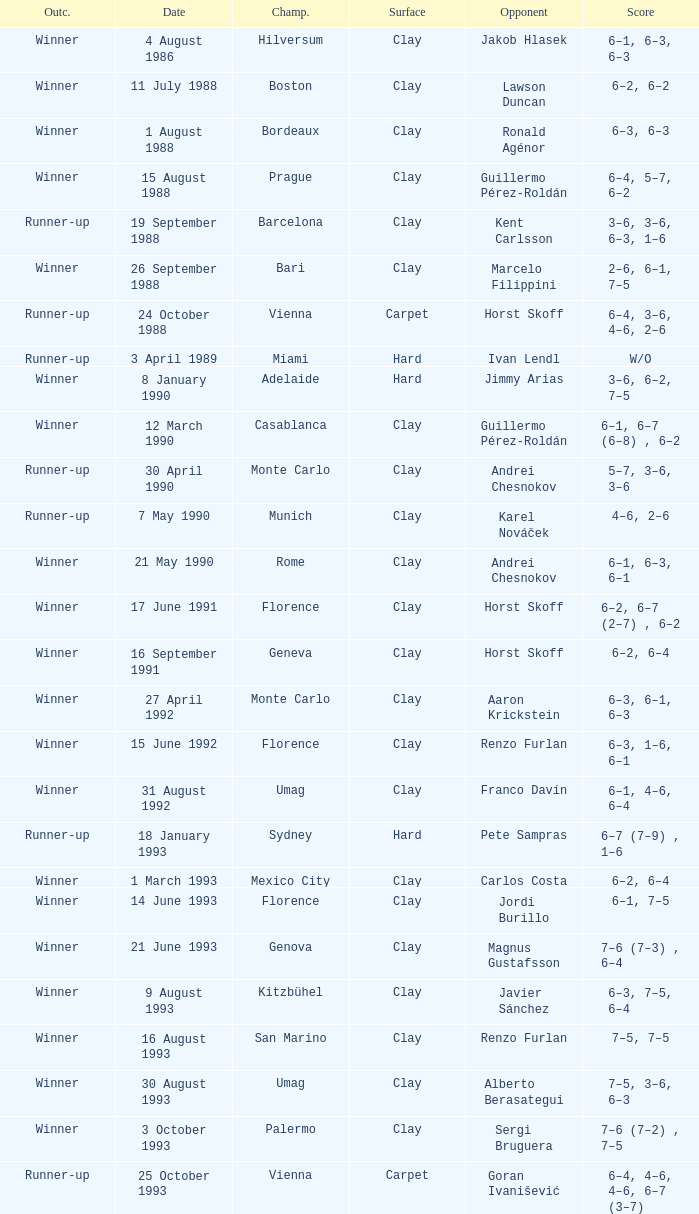What is the score when the championship is rome and the opponent is richard krajicek? 6–2, 6–4, 3–6, 6–3. 